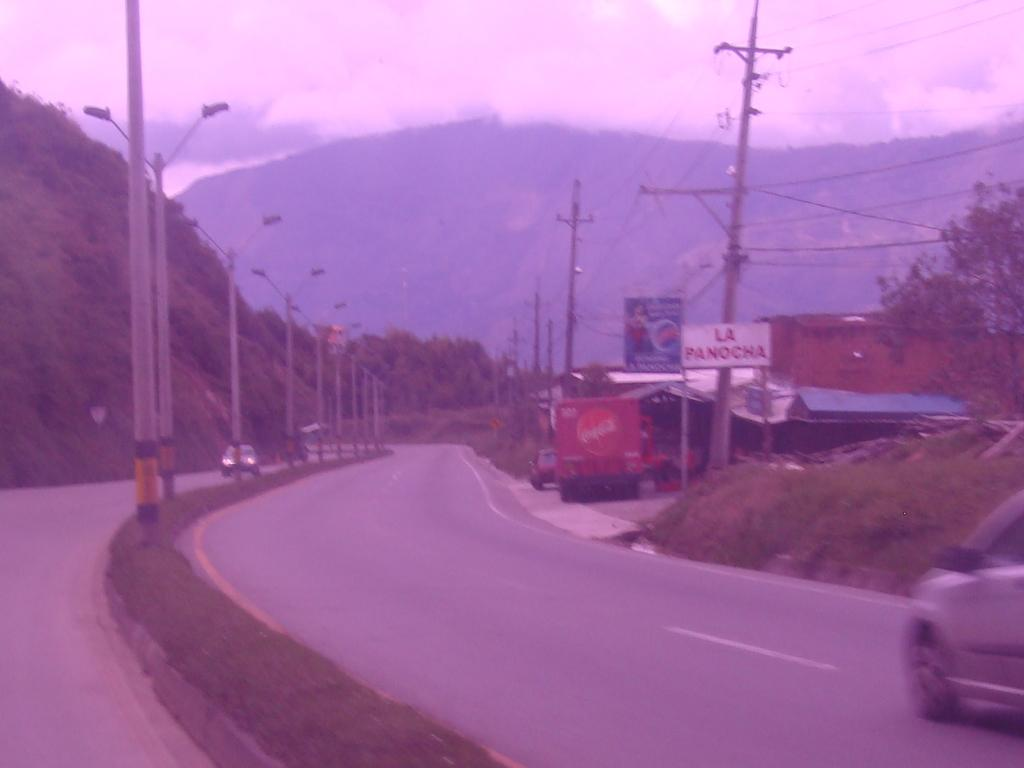What can be seen on the roads in the image? There are vehicles on the roads in the image. What type of structures are present in the image? Light poles and a shed are visible in the image. What type of signage is present in the image? Posters are visible in the image. What type of vegetation is present in the image? Trees and plants are present in the image. What type of natural landmarks are visible in the image? Mountains are visible in the image. What is visible in the background of the image? The sky is visible in the background of the image. What is present in the sky? Clouds are present in the sky. What other objects can be seen in the image? There are various objects in the image. Can you describe the operation of the giants in the image? There are no giants present in the image, so it is not possible to describe their operation. 